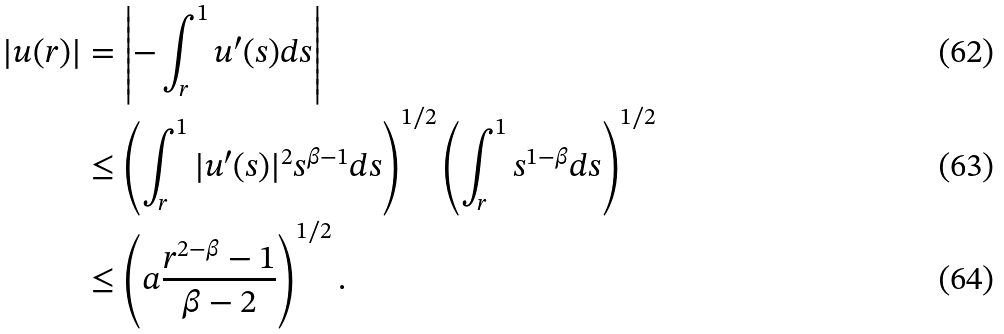Convert formula to latex. <formula><loc_0><loc_0><loc_500><loc_500>| u ( r ) | & = \left | - \int _ { r } ^ { 1 } u ^ { \prime } ( s ) d s \right | \\ & \leq \left ( \int _ { r } ^ { 1 } | u ^ { \prime } ( s ) | ^ { 2 } s ^ { \beta - 1 } d s \right ) ^ { 1 / 2 } \left ( \int _ { r } ^ { 1 } s ^ { 1 - \beta } d s \right ) ^ { 1 / 2 } \\ & \leq \left ( a \frac { r ^ { 2 - \beta } - 1 } { \beta - 2 } \right ) ^ { 1 / 2 } .</formula> 